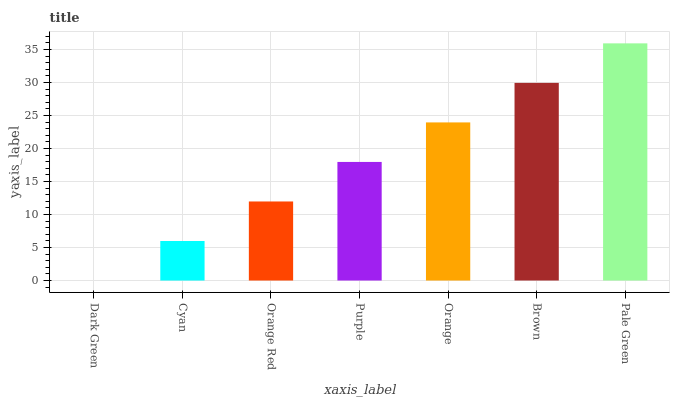Is Dark Green the minimum?
Answer yes or no. Yes. Is Pale Green the maximum?
Answer yes or no. Yes. Is Cyan the minimum?
Answer yes or no. No. Is Cyan the maximum?
Answer yes or no. No. Is Cyan greater than Dark Green?
Answer yes or no. Yes. Is Dark Green less than Cyan?
Answer yes or no. Yes. Is Dark Green greater than Cyan?
Answer yes or no. No. Is Cyan less than Dark Green?
Answer yes or no. No. Is Purple the high median?
Answer yes or no. Yes. Is Purple the low median?
Answer yes or no. Yes. Is Orange Red the high median?
Answer yes or no. No. Is Dark Green the low median?
Answer yes or no. No. 